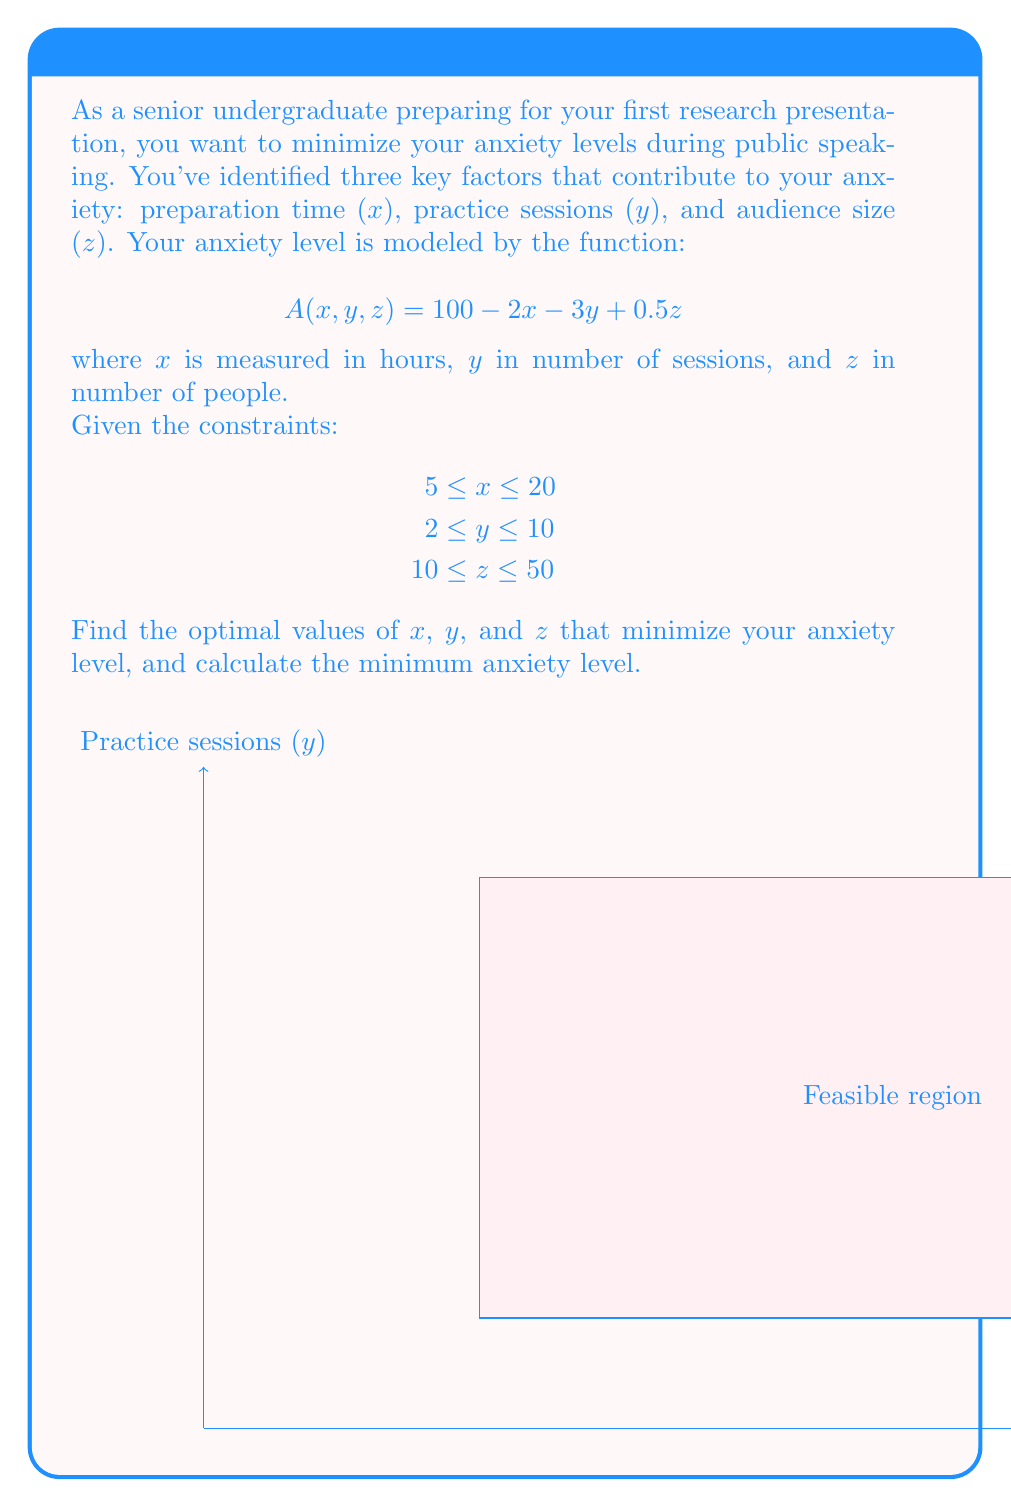Provide a solution to this math problem. Let's approach this step-by-step:

1) First, we need to recognize that this is a linear programming problem. The objective function (anxiety level) is linear, and the constraints are also linear.

2) In linear programming, the optimal solution always occurs at a corner point of the feasible region. The feasible region is defined by the constraints:

   $$5 \leq x \leq 20$$
   $$2 \leq y \leq 10$$
   $$10 \leq z \leq 50$$

3) To minimize anxiety, we need to:
   - Maximize x (because it has a negative coefficient)
   - Maximize y (because it has a negative coefficient)
   - Minimize z (because it has a positive coefficient)

4) Therefore, the optimal solution will be:
   $$x = 20$$ (maximum allowed)
   $$y = 10$$ (maximum allowed)
   $$z = 10$$ (minimum allowed)

5) Let's calculate the minimum anxiety level by plugging these values into the anxiety function:

   $$A(20,10,10) = 100 - 2(20) - 3(10) + 0.5(10)$$
   $$= 100 - 40 - 30 + 5$$
   $$= 35$$

Therefore, the minimum anxiety level is 35.
Answer: $x = 20$, $y = 10$, $z = 10$; Minimum anxiety level = 35 